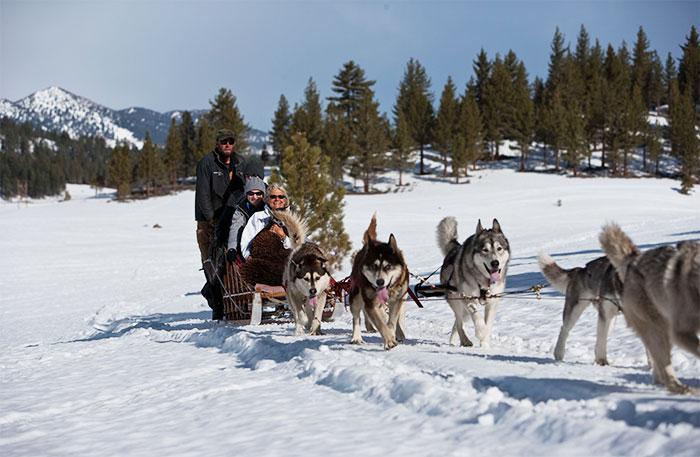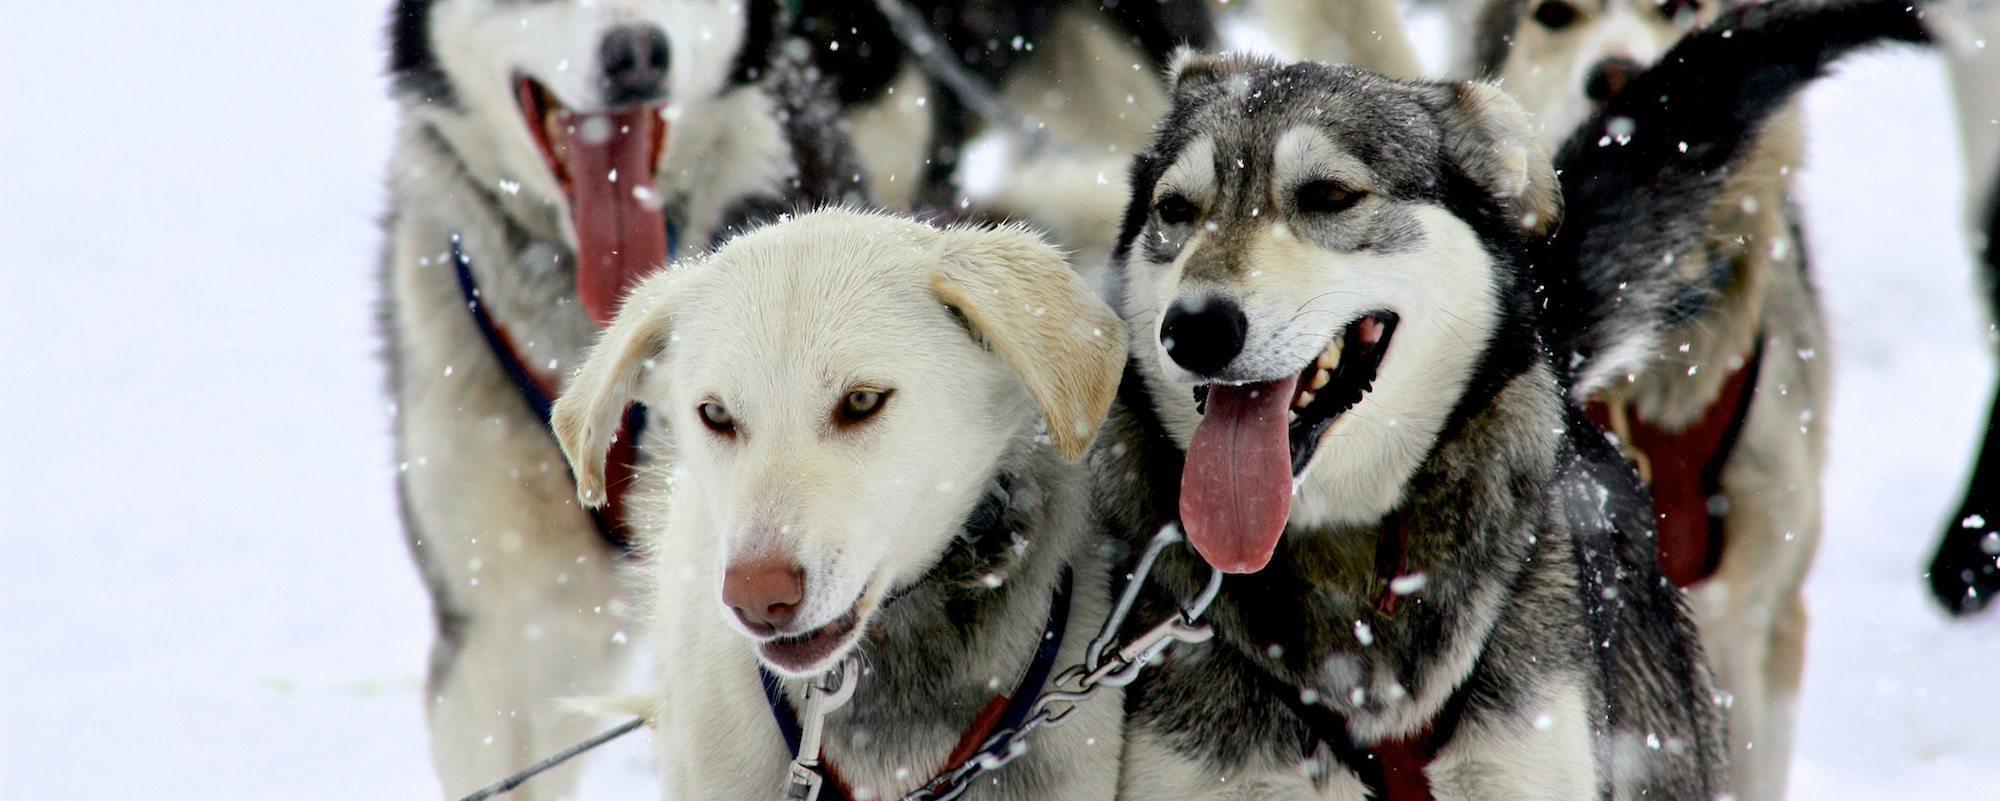The first image is the image on the left, the second image is the image on the right. Considering the images on both sides, is "sled dogs are wearing protective foot coverings" valid? Answer yes or no. No. The first image is the image on the left, the second image is the image on the right. Evaluate the accuracy of this statement regarding the images: "Some dogs are wearing booties.". Is it true? Answer yes or no. No. 